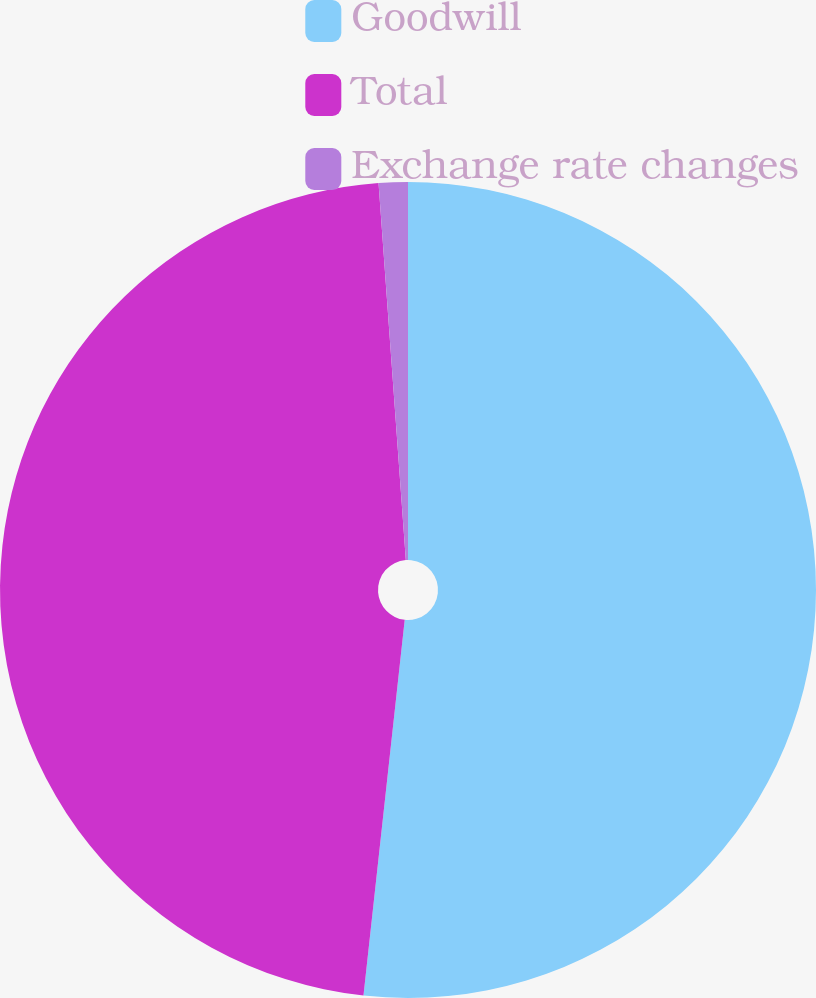<chart> <loc_0><loc_0><loc_500><loc_500><pie_chart><fcel>Goodwill<fcel>Total<fcel>Exchange rate changes<nl><fcel>51.74%<fcel>47.11%<fcel>1.15%<nl></chart> 